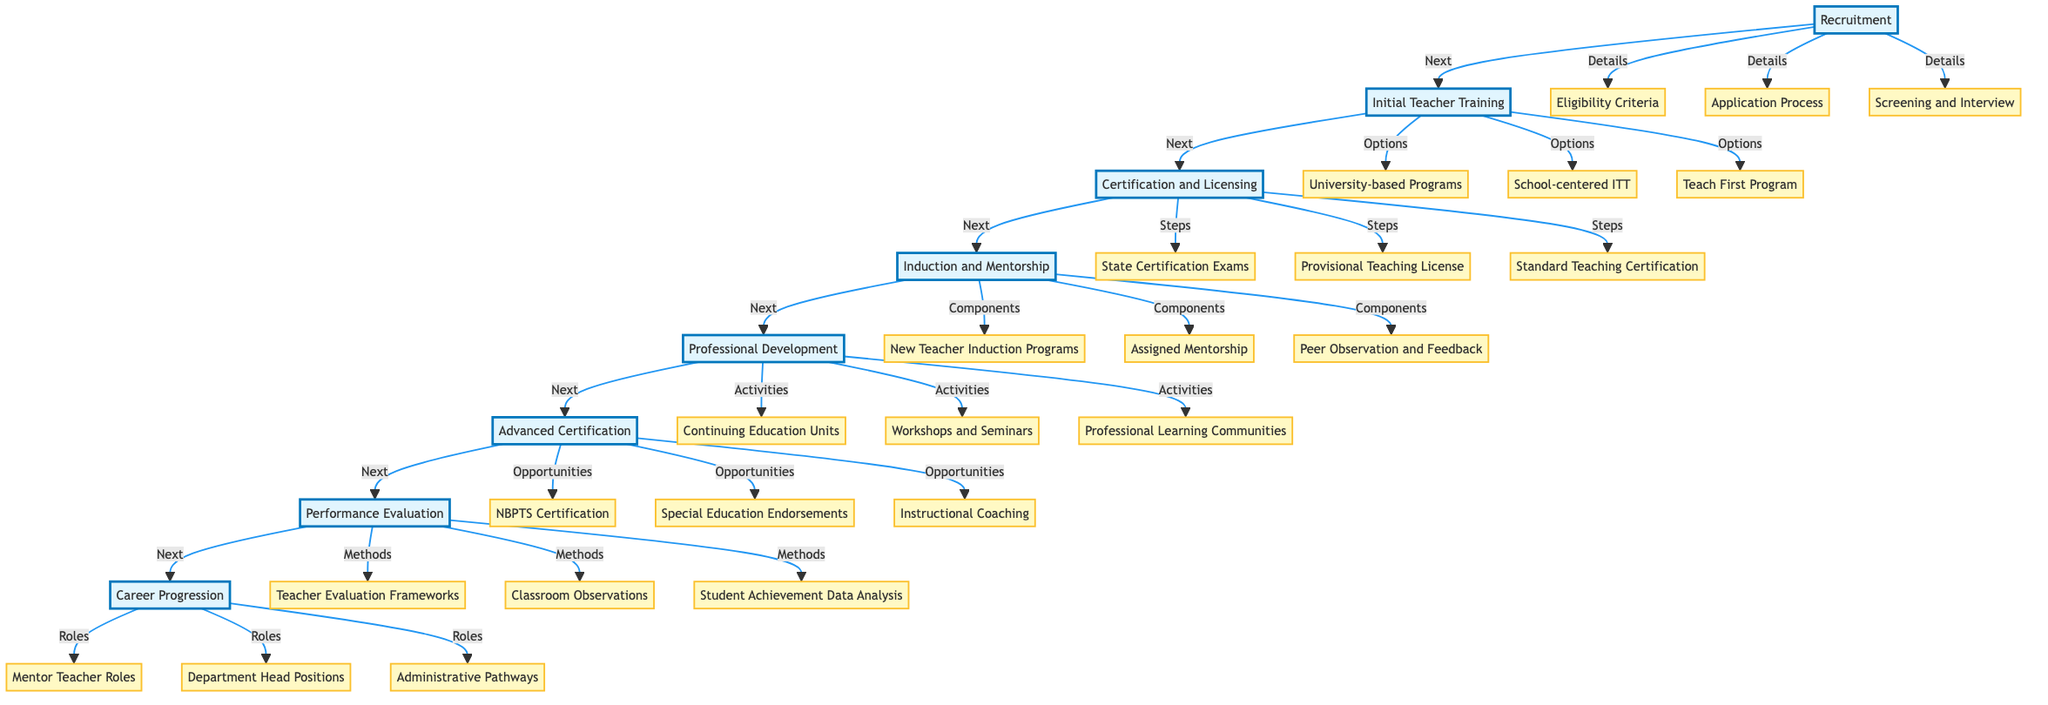What is the first step in the Teacher Training and Development Pathway? The diagram shows "Recruitment" as the first step, connected to the next element "Initial Teacher Training".
Answer: Recruitment How many main phases are there in the pathway? The diagram includes eight main phases: Recruitment, Initial Teacher Training, Certification and Licensing, Induction and Mentorship, Professional Development, Advanced Certification, Performance Evaluation, and Career Progression.
Answer: Eight Which element follows "Certification and Licensing"? The pathway flows from "Certification and Licensing" to "Induction and Mentorship", as indicated by the arrows connecting these nodes.
Answer: Induction and Mentorship What is one option under Initial Teacher Training? The second element, "Initial Teacher Training", includes multiple options, one of which is "School-centered Initial Teacher Training (SCITT)".
Answer: School-centered Initial Teacher Training What connections are present between "Performance Evaluation" and "Career Progression"? There is a direct connection from "Performance Evaluation" to "Career Progression", indicating that performance evaluations influence or lead to career advancement options.
Answer: Direct connection How does "Professional Development" contribute to a teacher's learning? "Professional Development" includes activities like Continuing Education Units, Workshops, and Professional Learning Communities, which are designed to enhance teacher skills and knowledge.
Answer: Enhancing skills What are two roles mentioned under Career Progression? The element "Career Progression" lists roles such as Mentor Teacher Roles and Department Head Positions, which denote levels or advancements in a teacher's career.
Answer: Mentor Teacher Roles, Department Head Positions How many detailed components are listed under Induction and Mentorship? There are three components listed under "Induction and Mentorship": New Teacher Induction Programs, Assigned Mentorship, and Peer Observation and Feedback.
Answer: Three Which certification is part of Advanced Certification and Specialization? The "Advanced Certification and Specialization" section includes the National Board for Professional Teaching Standards (NBPTS) Certification as one of the opportunities for further professional recognition.
Answer: National Board for Professional Teaching Standards Certification 